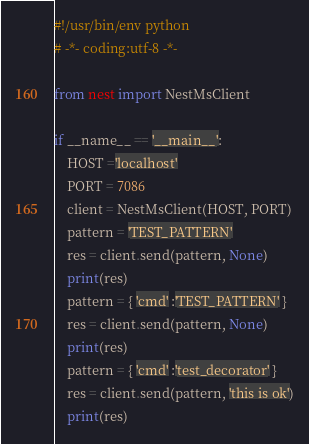<code> <loc_0><loc_0><loc_500><loc_500><_Python_>#!/usr/bin/env python
# -*- coding:utf-8 -*-

from nest import NestMsClient

if __name__ == '__main__':
    HOST ='localhost'
    PORT = 7086
    client = NestMsClient(HOST, PORT)
    pattern = 'TEST_PATTERN'
    res = client.send(pattern, None)
    print(res)
    pattern = { 'cmd' :'TEST_PATTERN' }
    res = client.send(pattern, None)
    print(res)
    pattern = { 'cmd' :'test_decorator' }
    res = client.send(pattern, 'this is ok')
    print(res)
</code> 